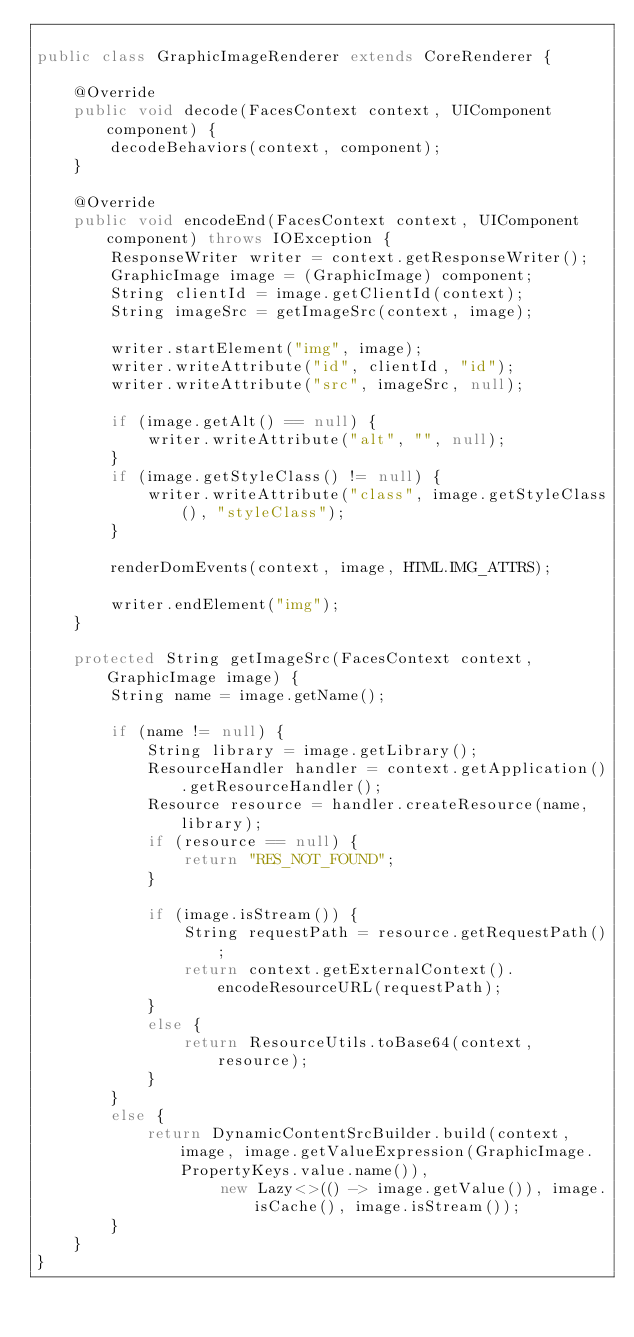<code> <loc_0><loc_0><loc_500><loc_500><_Java_>
public class GraphicImageRenderer extends CoreRenderer {

    @Override
    public void decode(FacesContext context, UIComponent component) {
        decodeBehaviors(context, component);
    }

    @Override
    public void encodeEnd(FacesContext context, UIComponent component) throws IOException {
        ResponseWriter writer = context.getResponseWriter();
        GraphicImage image = (GraphicImage) component;
        String clientId = image.getClientId(context);
        String imageSrc = getImageSrc(context, image);

        writer.startElement("img", image);
        writer.writeAttribute("id", clientId, "id");
        writer.writeAttribute("src", imageSrc, null);

        if (image.getAlt() == null) {
            writer.writeAttribute("alt", "", null);
        }
        if (image.getStyleClass() != null) {
            writer.writeAttribute("class", image.getStyleClass(), "styleClass");
        }

        renderDomEvents(context, image, HTML.IMG_ATTRS);

        writer.endElement("img");
    }

    protected String getImageSrc(FacesContext context, GraphicImage image) {
        String name = image.getName();

        if (name != null) {
            String library = image.getLibrary();
            ResourceHandler handler = context.getApplication().getResourceHandler();
            Resource resource = handler.createResource(name, library);
            if (resource == null) {
                return "RES_NOT_FOUND";
            }

            if (image.isStream()) {
                String requestPath = resource.getRequestPath();
                return context.getExternalContext().encodeResourceURL(requestPath);
            }
            else {
                return ResourceUtils.toBase64(context, resource);
            }
        }
        else {
            return DynamicContentSrcBuilder.build(context, image, image.getValueExpression(GraphicImage.PropertyKeys.value.name()),
                    new Lazy<>(() -> image.getValue()), image.isCache(), image.isStream());
        }
    }
}
</code> 